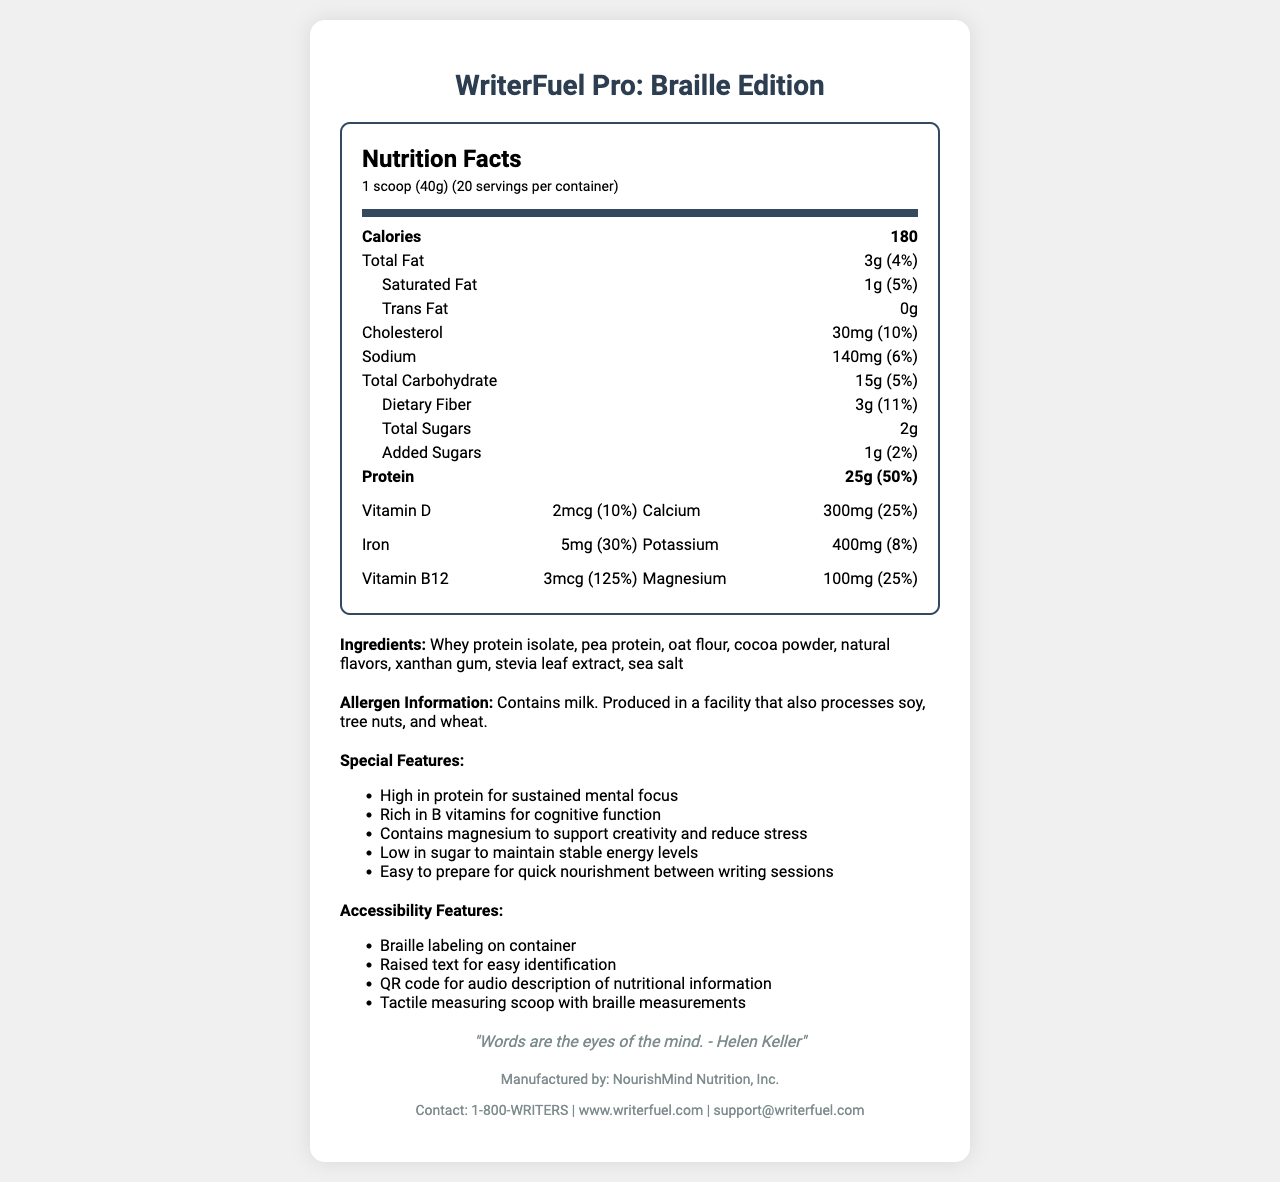what is the serving size? The serving size is specified at the beginning of the nutrition facts section as "1 scoop (40g)".
Answer: 1 scoop (40g) how many calories are in one serving? The document lists the calorie content of one serving as 180 calories.
Answer: 180 calories what is the total fat per serving? Under the nutrition facts, it states that each serving contains 3g of total fat.
Answer: 3g what is the amount of protein per serving? The protein content per serving is listed as 25g in the nutrition facts section.
Answer: 25g which vitamin has the highest percent daily value? Among the listed vitamins and minerals, Vitamin B12 has the highest percent daily value at 125%.
Answer: Vitamin B12 (125%) how many servings per container? The document states there are 20 servings per container.
Answer: 20 is there any trans fat in the product? The nutrition facts label lists trans fat as 0g, indicating there is no trans fat in the product.
Answer: No what are the special features of the product? The special features are listed directly in the document under the "Special Features" section.
Answer: High in protein for sustained mental focus, Rich in B vitamins for cognitive function, Contains magnesium to support creativity and reduce stress, Low in sugar to maintain stable energy levels, Easy to prepare for quick nourishment between writing sessions which ingredient is listed first? The ingredients section lists whey protein isolate as the first ingredient.
Answer: Whey protein isolate does the product contain gluten? The allergen information mentions that the product is produced in a facility that also processes wheat, but it does not explicitly state whether the product itself contains gluten.
Answer: not enough information what is the percent daily value of calcium per serving? A. 10% B. 25% C. 30% D. 40% The percent daily value of calcium per serving is listed as 25%.
Answer: B. 25% which of the following features helps with accessibility? A. Easy to prepare B. Braille labeling on container C. Rich in B vitamins D. High in protein This feature is specifically mentioned under the accessibility features section.
Answer: B. Braille labeling on container is the product supposed to help with cognitive function? One of the special features specifically mentions that the product is rich in B vitamins for cognitive function.
Answer: Yes does the product contain artificial sweeteners? The sweetener used is stevia leaf extract, which is a natural sweetener.
Answer: No summary of the document The document provides an overview of the nutrition facts, special features, accessibility features, and manufacturer information for the meal replacement shake called "WriterFuel Pro: Braille Edition".
Answer: The document provides detailed information about a meal replacement shake called "WriterFuel Pro: Braille Edition". It includes the nutrition facts such as serving size, calorie count, and macronutrients. The product is rich in protein and B vitamins and is low in sugar. It also lists various vitamins and minerals with their amounts and percent daily values. There are accessibility features like Braille labeling, raised text, and a QR code for audio descriptions. The document also highlights the product's special features, ingredients, allergen information, and contact details for the manufacturer. The document ends with an inspirational quote from Helen Keller. how much cholesterol does one serving contain? The nutrition facts section indicates that one serving contains 30mg of cholesterol.
Answer: 30mg who manufactures the product? The manufacturer information at the end of the document lists NourishMind Nutrition, Inc.
Answer: NourishMind Nutrition, Inc. how do you contact the manufacturer? The manufacturer's contact information provided includes a phone number, website, and email address.
Answer: 1-800-WRITERS, www.writerfuel.com, support@writerfuel.com 